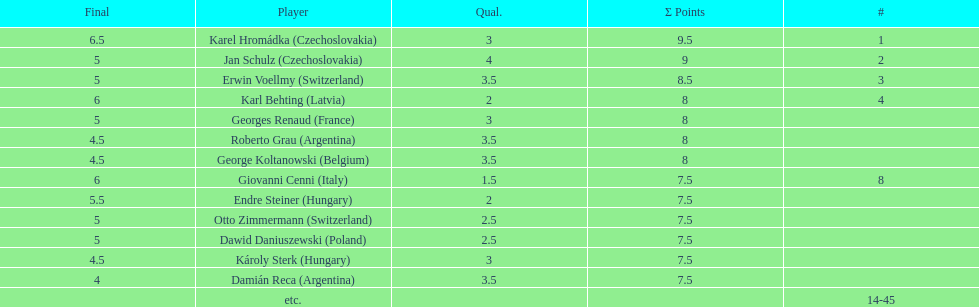Did the two competitors from hungary get more or less combined points than the two competitors from argentina? Less. 